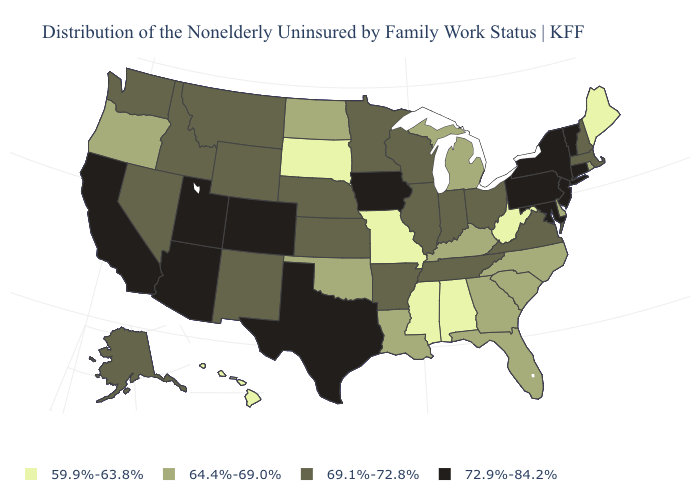Does Maryland have a higher value than Colorado?
Concise answer only. No. Does the map have missing data?
Concise answer only. No. What is the highest value in states that border Massachusetts?
Concise answer only. 72.9%-84.2%. Among the states that border Vermont , which have the lowest value?
Give a very brief answer. Massachusetts, New Hampshire. Does Pennsylvania have the highest value in the USA?
Answer briefly. Yes. Does the first symbol in the legend represent the smallest category?
Keep it brief. Yes. Which states have the highest value in the USA?
Write a very short answer. Arizona, California, Colorado, Connecticut, Iowa, Maryland, New Jersey, New York, Pennsylvania, Texas, Utah, Vermont. Does Rhode Island have the highest value in the USA?
Give a very brief answer. No. Name the states that have a value in the range 72.9%-84.2%?
Be succinct. Arizona, California, Colorado, Connecticut, Iowa, Maryland, New Jersey, New York, Pennsylvania, Texas, Utah, Vermont. What is the value of Louisiana?
Be succinct. 64.4%-69.0%. What is the lowest value in states that border South Carolina?
Quick response, please. 64.4%-69.0%. Name the states that have a value in the range 64.4%-69.0%?
Answer briefly. Delaware, Florida, Georgia, Kentucky, Louisiana, Michigan, North Carolina, North Dakota, Oklahoma, Oregon, Rhode Island, South Carolina. Does Washington have the same value as Nevada?
Quick response, please. Yes. What is the highest value in the South ?
Short answer required. 72.9%-84.2%. What is the value of Illinois?
Concise answer only. 69.1%-72.8%. 